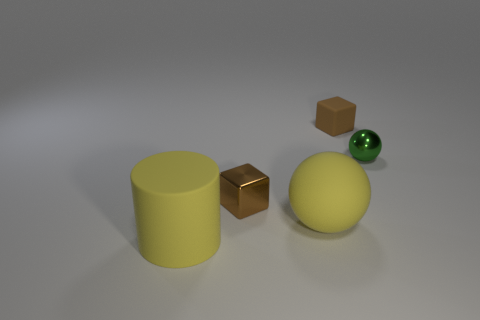The brown thing that is on the right side of the brown object to the left of the big rubber sphere is made of what material?
Your response must be concise. Rubber. How big is the brown thing that is behind the brown metal thing?
Keep it short and to the point. Small. What is the color of the thing that is both to the left of the large rubber ball and behind the large rubber ball?
Give a very brief answer. Brown. There is a sphere behind the brown shiny object; is it the same size as the yellow sphere?
Provide a succinct answer. No. Are there any metallic objects that are in front of the large matte object left of the brown metal object?
Offer a terse response. No. What is the green ball made of?
Offer a very short reply. Metal. Are there any small shiny objects to the right of the green sphere?
Your answer should be very brief. No. What size is the yellow object that is the same shape as the green shiny object?
Keep it short and to the point. Large. Are there an equal number of small metallic cubes to the right of the brown matte cube and brown shiny things that are right of the matte ball?
Offer a very short reply. Yes. What number of tiny metal cubes are there?
Offer a terse response. 1. 